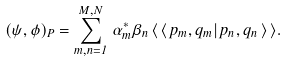Convert formula to latex. <formula><loc_0><loc_0><loc_500><loc_500>( \psi , \phi ) _ { P } = \sum _ { m , n = 1 } ^ { M , N } \, \alpha ^ { \ast } _ { m } \beta _ { n } \, \langle \, \langle \, p _ { m } , q _ { m } | \, p _ { n } , q _ { n } \, \rangle \, \rangle .</formula> 